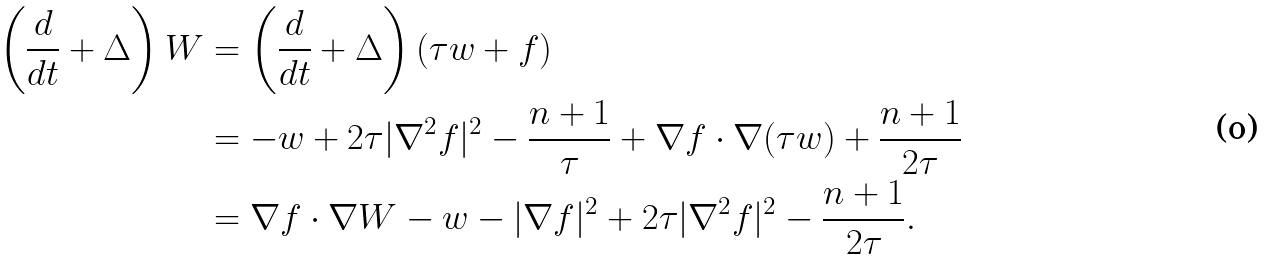Convert formula to latex. <formula><loc_0><loc_0><loc_500><loc_500>\left ( \frac { d } { d t } + \Delta \right ) W & = \left ( \frac { d } { d t } + \Delta \right ) ( \tau w + f ) \\ & = - w + 2 \tau | \nabla ^ { 2 } f | ^ { 2 } - \frac { n + 1 } { \tau } + \nabla f \cdot \nabla ( \tau w ) + \frac { n + 1 } { 2 \tau } \\ & = \nabla f \cdot \nabla W - w - | \nabla f | ^ { 2 } + 2 \tau | \nabla ^ { 2 } f | ^ { 2 } - \frac { n + 1 } { 2 \tau } .</formula> 